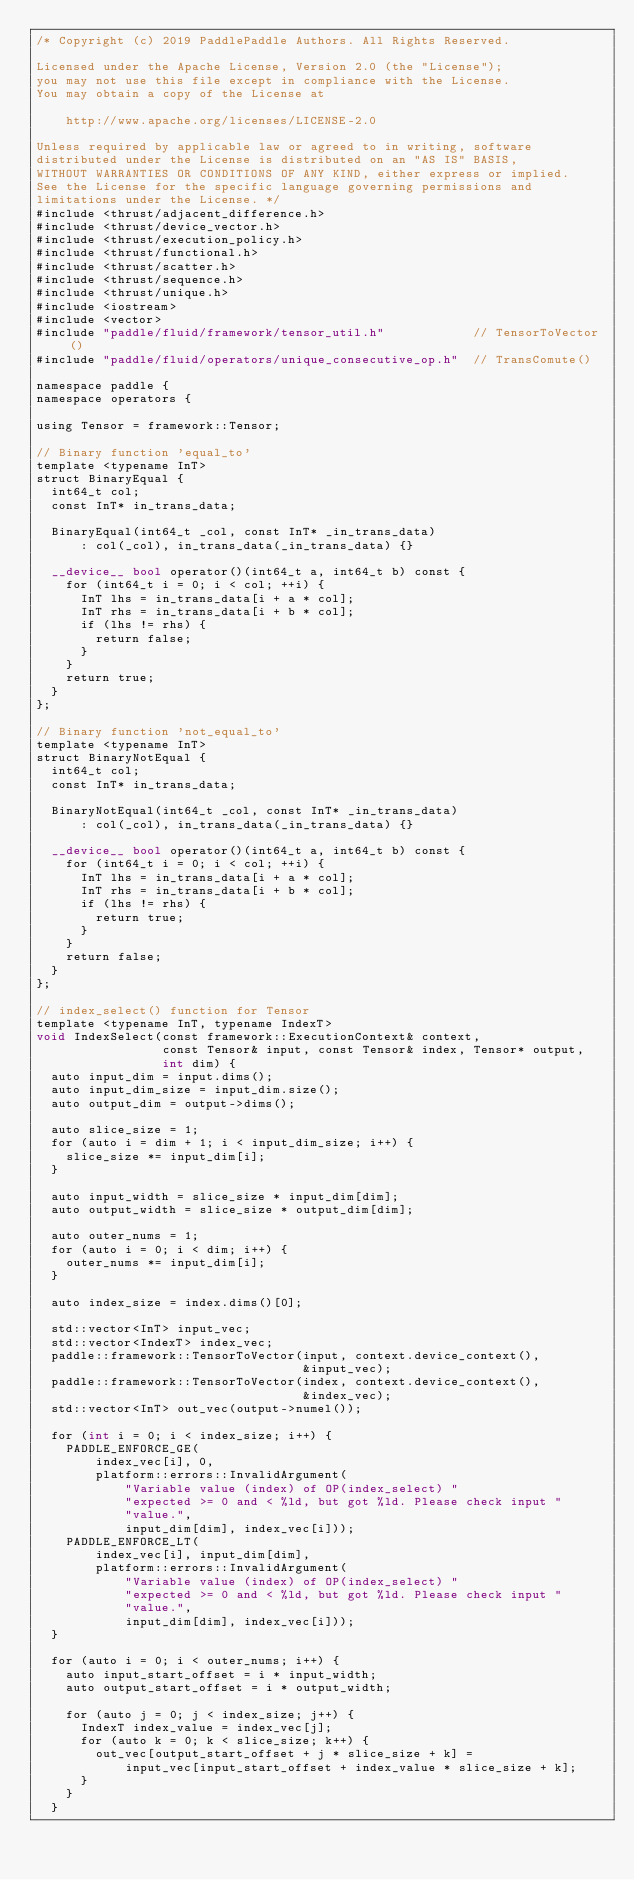Convert code to text. <code><loc_0><loc_0><loc_500><loc_500><_Cuda_>/* Copyright (c) 2019 PaddlePaddle Authors. All Rights Reserved.

Licensed under the Apache License, Version 2.0 (the "License");
you may not use this file except in compliance with the License.
You may obtain a copy of the License at

    http://www.apache.org/licenses/LICENSE-2.0

Unless required by applicable law or agreed to in writing, software
distributed under the License is distributed on an "AS IS" BASIS,
WITHOUT WARRANTIES OR CONDITIONS OF ANY KIND, either express or implied.
See the License for the specific language governing permissions and
limitations under the License. */
#include <thrust/adjacent_difference.h>
#include <thrust/device_vector.h>
#include <thrust/execution_policy.h>
#include <thrust/functional.h>
#include <thrust/scatter.h>
#include <thrust/sequence.h>
#include <thrust/unique.h>
#include <iostream>
#include <vector>
#include "paddle/fluid/framework/tensor_util.h"            // TensorToVector()
#include "paddle/fluid/operators/unique_consecutive_op.h"  // TransComute()

namespace paddle {
namespace operators {

using Tensor = framework::Tensor;

// Binary function 'equal_to'
template <typename InT>
struct BinaryEqual {
  int64_t col;
  const InT* in_trans_data;

  BinaryEqual(int64_t _col, const InT* _in_trans_data)
      : col(_col), in_trans_data(_in_trans_data) {}

  __device__ bool operator()(int64_t a, int64_t b) const {
    for (int64_t i = 0; i < col; ++i) {
      InT lhs = in_trans_data[i + a * col];
      InT rhs = in_trans_data[i + b * col];
      if (lhs != rhs) {
        return false;
      }
    }
    return true;
  }
};

// Binary function 'not_equal_to'
template <typename InT>
struct BinaryNotEqual {
  int64_t col;
  const InT* in_trans_data;

  BinaryNotEqual(int64_t _col, const InT* _in_trans_data)
      : col(_col), in_trans_data(_in_trans_data) {}

  __device__ bool operator()(int64_t a, int64_t b) const {
    for (int64_t i = 0; i < col; ++i) {
      InT lhs = in_trans_data[i + a * col];
      InT rhs = in_trans_data[i + b * col];
      if (lhs != rhs) {
        return true;
      }
    }
    return false;
  }
};

// index_select() function for Tensor
template <typename InT, typename IndexT>
void IndexSelect(const framework::ExecutionContext& context,
                 const Tensor& input, const Tensor& index, Tensor* output,
                 int dim) {
  auto input_dim = input.dims();
  auto input_dim_size = input_dim.size();
  auto output_dim = output->dims();

  auto slice_size = 1;
  for (auto i = dim + 1; i < input_dim_size; i++) {
    slice_size *= input_dim[i];
  }

  auto input_width = slice_size * input_dim[dim];
  auto output_width = slice_size * output_dim[dim];

  auto outer_nums = 1;
  for (auto i = 0; i < dim; i++) {
    outer_nums *= input_dim[i];
  }

  auto index_size = index.dims()[0];

  std::vector<InT> input_vec;
  std::vector<IndexT> index_vec;
  paddle::framework::TensorToVector(input, context.device_context(),
                                    &input_vec);
  paddle::framework::TensorToVector(index, context.device_context(),
                                    &index_vec);
  std::vector<InT> out_vec(output->numel());

  for (int i = 0; i < index_size; i++) {
    PADDLE_ENFORCE_GE(
        index_vec[i], 0,
        platform::errors::InvalidArgument(
            "Variable value (index) of OP(index_select) "
            "expected >= 0 and < %ld, but got %ld. Please check input "
            "value.",
            input_dim[dim], index_vec[i]));
    PADDLE_ENFORCE_LT(
        index_vec[i], input_dim[dim],
        platform::errors::InvalidArgument(
            "Variable value (index) of OP(index_select) "
            "expected >= 0 and < %ld, but got %ld. Please check input "
            "value.",
            input_dim[dim], index_vec[i]));
  }

  for (auto i = 0; i < outer_nums; i++) {
    auto input_start_offset = i * input_width;
    auto output_start_offset = i * output_width;

    for (auto j = 0; j < index_size; j++) {
      IndexT index_value = index_vec[j];
      for (auto k = 0; k < slice_size; k++) {
        out_vec[output_start_offset + j * slice_size + k] =
            input_vec[input_start_offset + index_value * slice_size + k];
      }
    }
  }</code> 